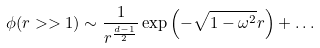Convert formula to latex. <formula><loc_0><loc_0><loc_500><loc_500>\phi ( r > > 1 ) \sim \frac { 1 } { r ^ { \frac { d - 1 } { 2 } } } \exp \left ( - \sqrt { 1 - \omega ^ { 2 } } r \right ) + \dots</formula> 